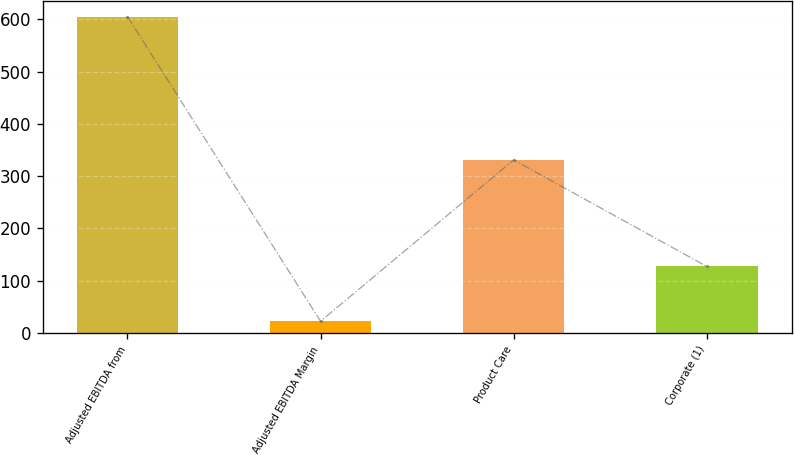Convert chart to OTSL. <chart><loc_0><loc_0><loc_500><loc_500><bar_chart><fcel>Adjusted EBITDA from<fcel>Adjusted EBITDA Margin<fcel>Product Care<fcel>Corporate (1)<nl><fcel>605.4<fcel>22.5<fcel>331.1<fcel>127.3<nl></chart> 